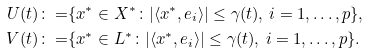Convert formula to latex. <formula><loc_0><loc_0><loc_500><loc_500>U ( t ) \colon = & \{ x ^ { \ast } \in X ^ { \ast } \colon | \langle x ^ { \ast } , e _ { i } \rangle | \leq \gamma ( t ) , \, i = 1 , \dots , p \} , \\ V ( t ) \colon = & \{ x ^ { \ast } \in L ^ { \ast } \colon | \langle x ^ { \ast } , e _ { i } \rangle | \leq \gamma ( t ) , \, i = 1 , \dots , p \} .</formula> 